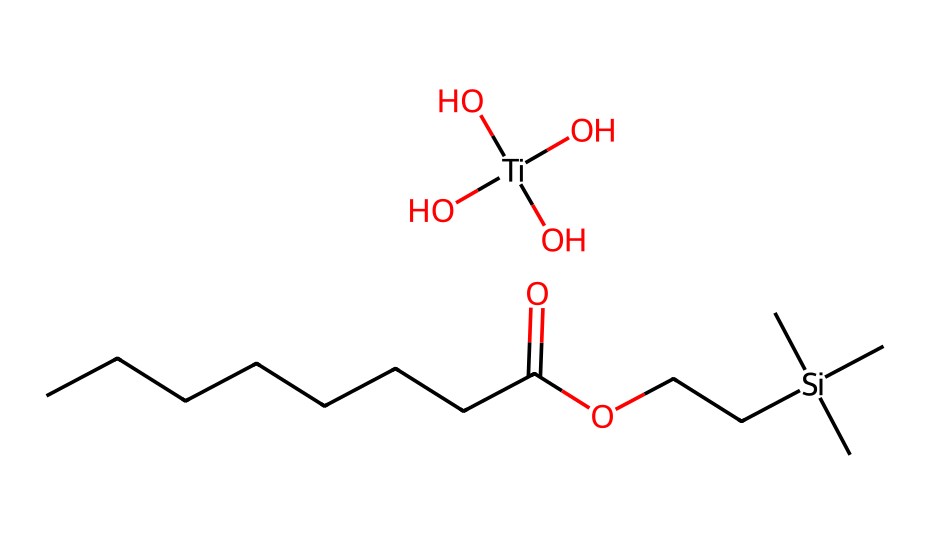What metal is present in this chemical? The SMILES representation shows the presence of titanium indicated by [Ti].
Answer: titanium How many hydroxyl groups are in the titanium compound? The representation shows three O atoms connected to the titanium, which indicates three hydroxyl groups.
Answer: three What is the main organic moiety in this compound? The structure contains a long carbon chain followed by a carboxylic acid group (CCCCC...C(=O)O), indicating it is a fatty acid ester.
Answer: fatty acid What type of bonding is likely present between titanium and the oxygen atoms? Titanium typically forms coordination bonds with oxygen in hydroxyl groups, suggesting coordination chemistry.
Answer: coordination How many carbon atoms are in the organic part of the molecule? Count the carbon atoms in the SMILES for the hydrocarbon chain, which shows a total of eight carbon atoms in the CCCCCCCC sequence.
Answer: eight Why is titanium dioxide used in sunscreens? Titanium dioxide is well known for its UV-filtering properties, making it effective in blocking harmful UV radiation.
Answer: UV-filter 